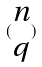Convert formula to latex. <formula><loc_0><loc_0><loc_500><loc_500>( \begin{matrix} n \\ q \end{matrix} )</formula> 